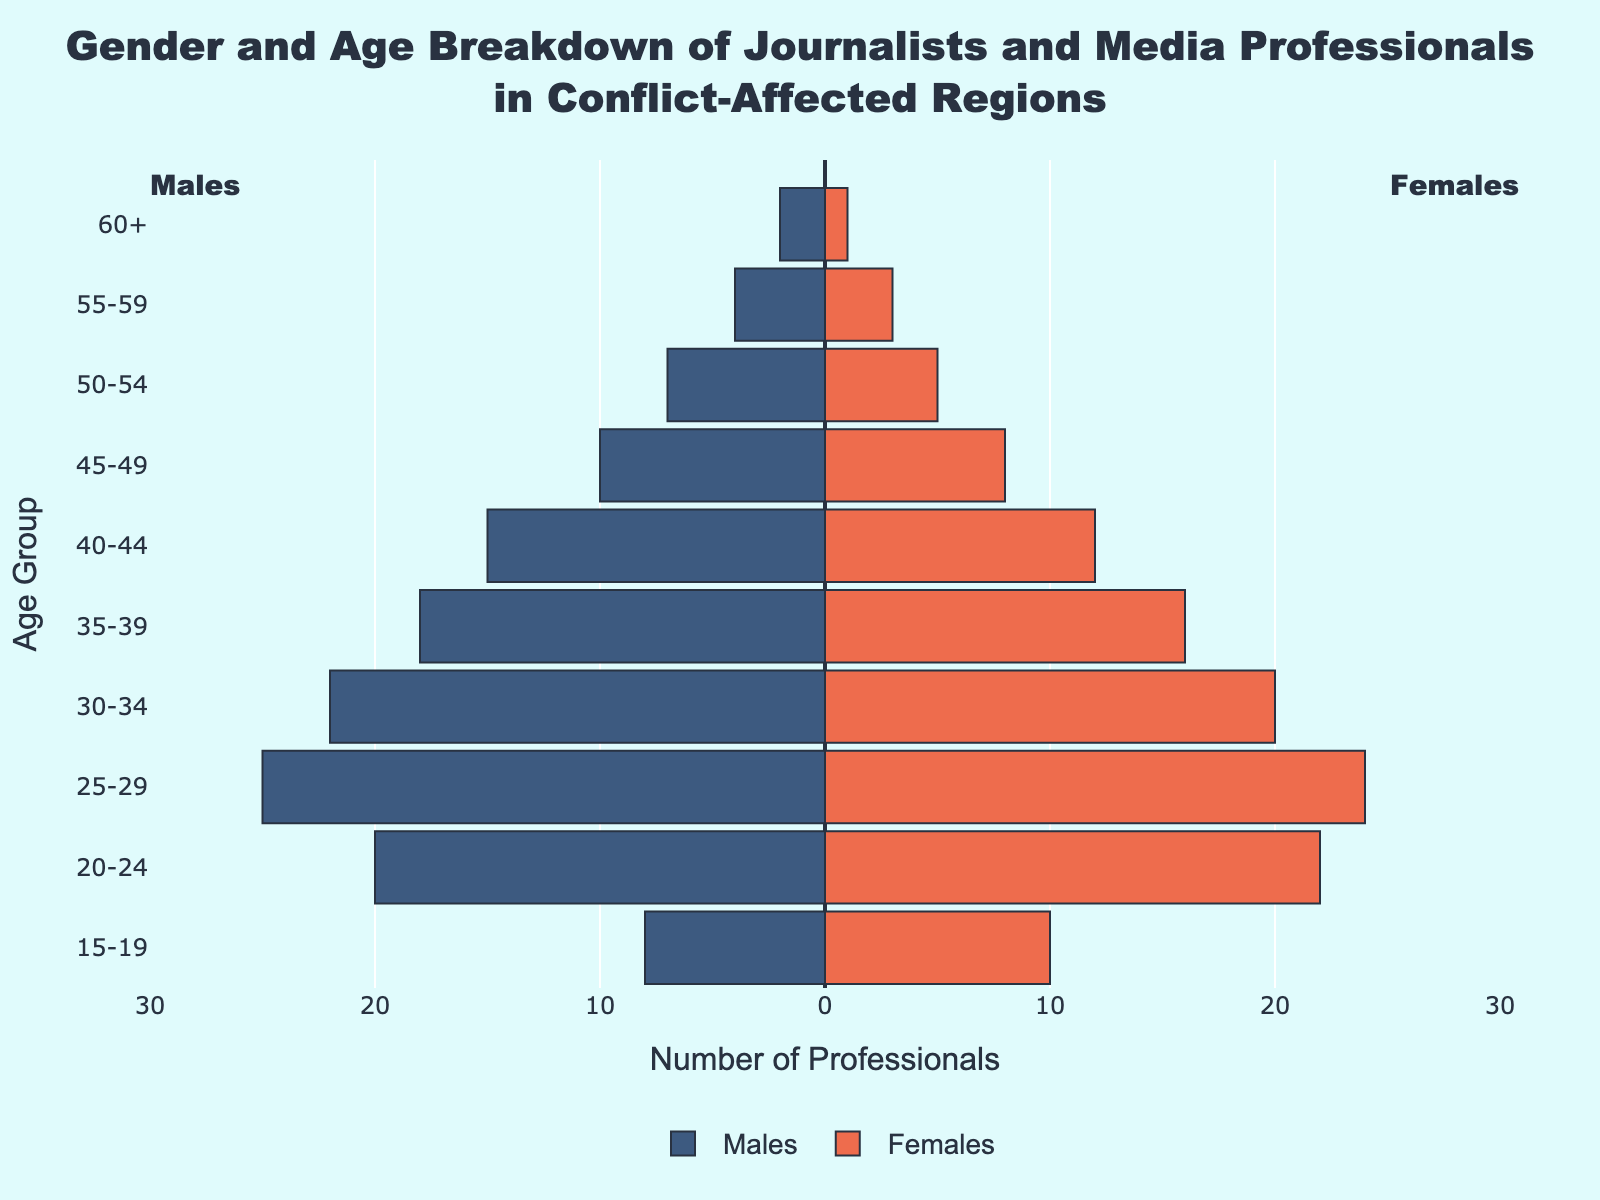Which age group has the highest number of male media professionals? The number of male media professionals can be visually compared by the length of the bars on the left side of the pyramid. The longest bar on the left corresponds to the '25-29' age group.
Answer: 25-29 Which age group has more female media professionals, '20-24' or '25-29'? Compare the lengths of the bars on the right side of the pyramid for the respective age groups. The bar for '25-29' is longer than that of '20-24', indicating more females in '25-29'.
Answer: 25-29 What is the total number of female media professionals in the '30-34' and '35-39' age groups? Add the number of females in both age groups: 20 (for '30-34') and 16 (for '35-39'), giving a total of 36.
Answer: 36 Are there more male or female media professionals in the '40-44' age group? Compare the lengths of the bars for males and females in the '40-44' age group. The bar for males is longer, indicating more males.
Answer: Males What is the total number of media professionals in the '55-59' age group? Calculate the sum of males and females in the '55-59' age group: 4 males + 3 females = 7.
Answer: 7 How does the number of male media professionals aged 50-54 compare to those aged 60+? Compare the lengths of the bars for males in these age groups. There are 7 in '50-54' and 2 in '60+', showing more males in '50-54'.
Answer: More males in 50-54 Which gender has the highest number of professionals in the 15-19 age group? Compare the lengths of the bars for males and females in the '15-19' age group. The bar for females is longer, indicating more females.
Answer: Females What is the difference in the number of male and female media professionals in the '25-29' age group? Subtract the number of females from the number of males in the '25-29' age group: 25 males - 24 females = 1.
Answer: 1 What is the combined total number of male media professionals in the age groups '30-34' and '35-39'? Add the number of males in both age groups: 22 (for '30-34') + 18 (for '35-39') = 40.
Answer: 40 Which age group shows the most balanced gender distribution among media professionals? Identify the age group where the lengths of the bars for males and females are closest in length. In this case, '25-29' shows the most balanced distribution with 25 males and 24 females.
Answer: 25-29 